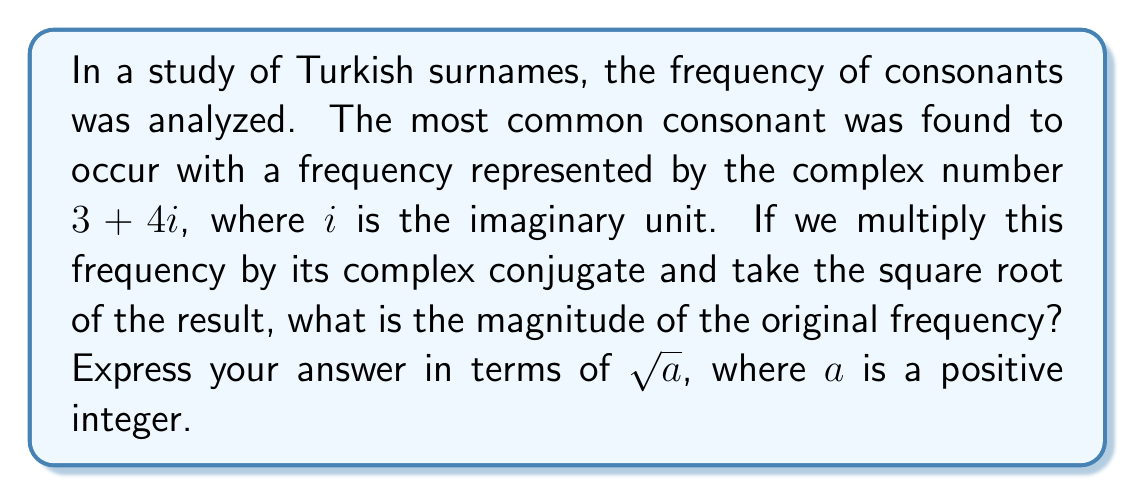What is the answer to this math problem? To solve this problem, we'll follow these steps:

1) The given complex number representing the frequency is $z = 3 + 4i$.

2) The complex conjugate of $z$ is $\overline{z} = 3 - 4i$.

3) Multiply $z$ by its complex conjugate:
   $z \cdot \overline{z} = (3 + 4i)(3 - 4i)$
   $= 9 - 12i + 12i - 16i^2$
   $= 9 + 16$ (since $i^2 = -1$)
   $= 25$

4) The magnitude of a complex number is given by the square root of the product of the number and its complex conjugate:
   $|z| = \sqrt{z \cdot \overline{z}}$

5) In this case:
   $|z| = \sqrt{25} = 5$

6) We need to express this in terms of $\sqrt{a}$, where $a$ is a positive integer.
   $5 = \sqrt{25}$, so $a = 25$.

Therefore, the magnitude of the original frequency is $\sqrt{25}$.
Answer: $\sqrt{25}$ 